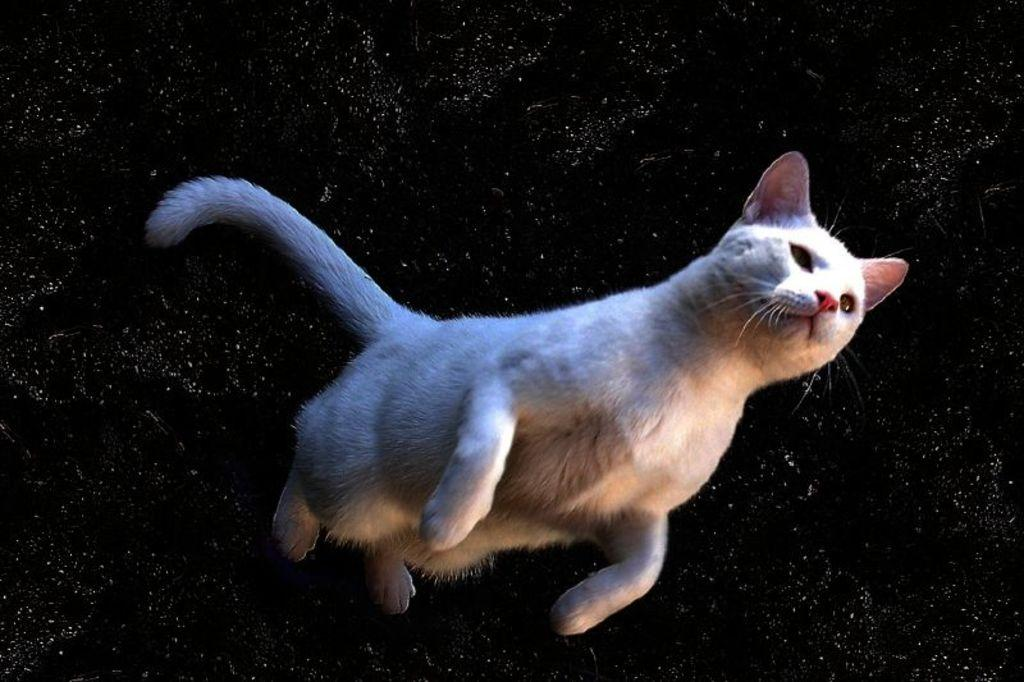What is the main subject of the image? There is a cat in the center of the image. Can you describe the appearance of the cat? The cat is white in color. What else can be seen in the image besides the cat? There are other objects visible in the background of the image. How many balloons are being pushed by the cat in the image? There are no balloons or any indication of pushing in the image; it features a white cat in the center. 